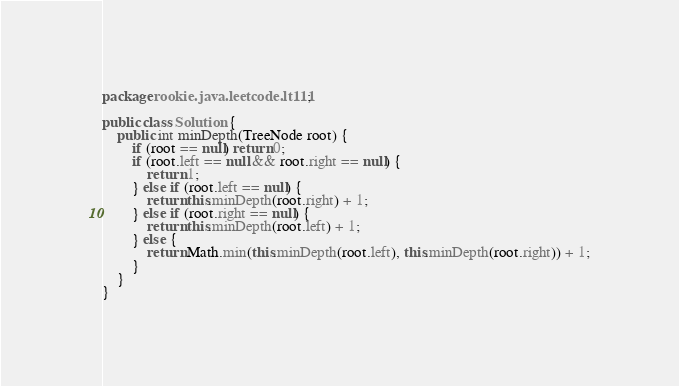<code> <loc_0><loc_0><loc_500><loc_500><_Java_>package rookie.java.leetcode.lt111;

public class Solution {
	public int minDepth(TreeNode root) {
		if (root == null) return 0;
		if (root.left == null && root.right == null) {
			return 1;
		} else if (root.left == null) {
			return this.minDepth(root.right) + 1;
		} else if (root.right == null) {
			return this.minDepth(root.left) + 1;
		} else {
			return Math.min(this.minDepth(root.left), this.minDepth(root.right)) + 1;
		}
    }
}
</code> 